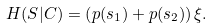Convert formula to latex. <formula><loc_0><loc_0><loc_500><loc_500>H ( S | C ) = \left ( p ( s _ { 1 } ) + p ( s _ { 2 } ) \right ) \xi .</formula> 